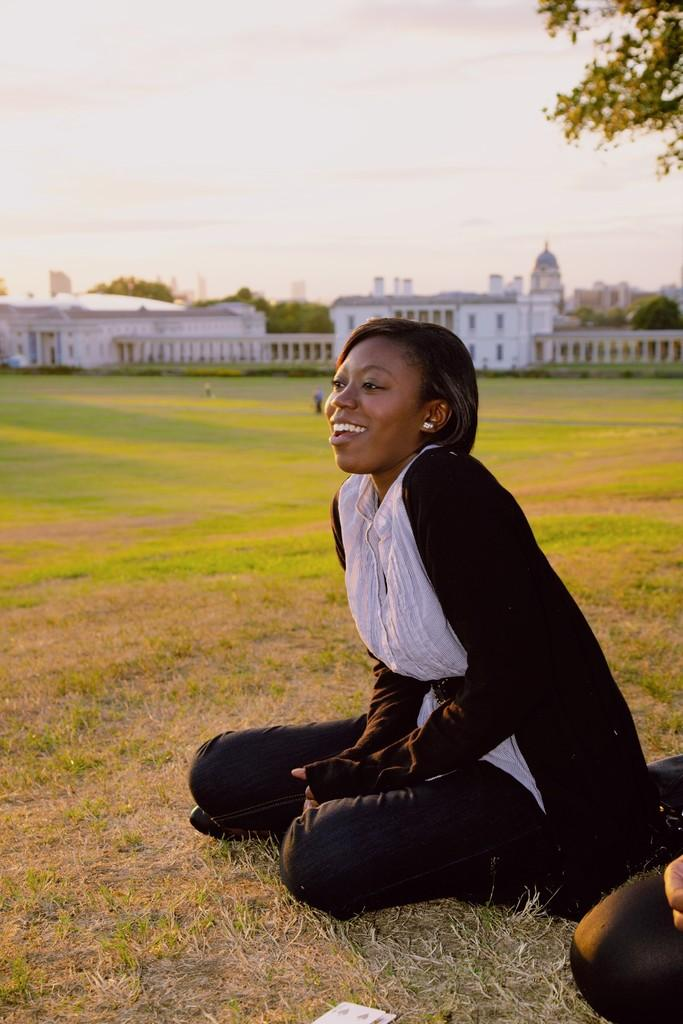What is the woman in the image doing? The woman is sitting on the ground in the image. What can be seen in the background of the image? There are buildings, a fence, trees, and the sky visible in the background of the image. What is the condition of the sky in the image? The sky is visible in the background of the image, and clouds are present. How many deer can be seen in the image? There are no deer present in the image. What type of alarm is the woman holding in the image? There is no alarm visible in the image; the woman is simply sitting on the ground. 